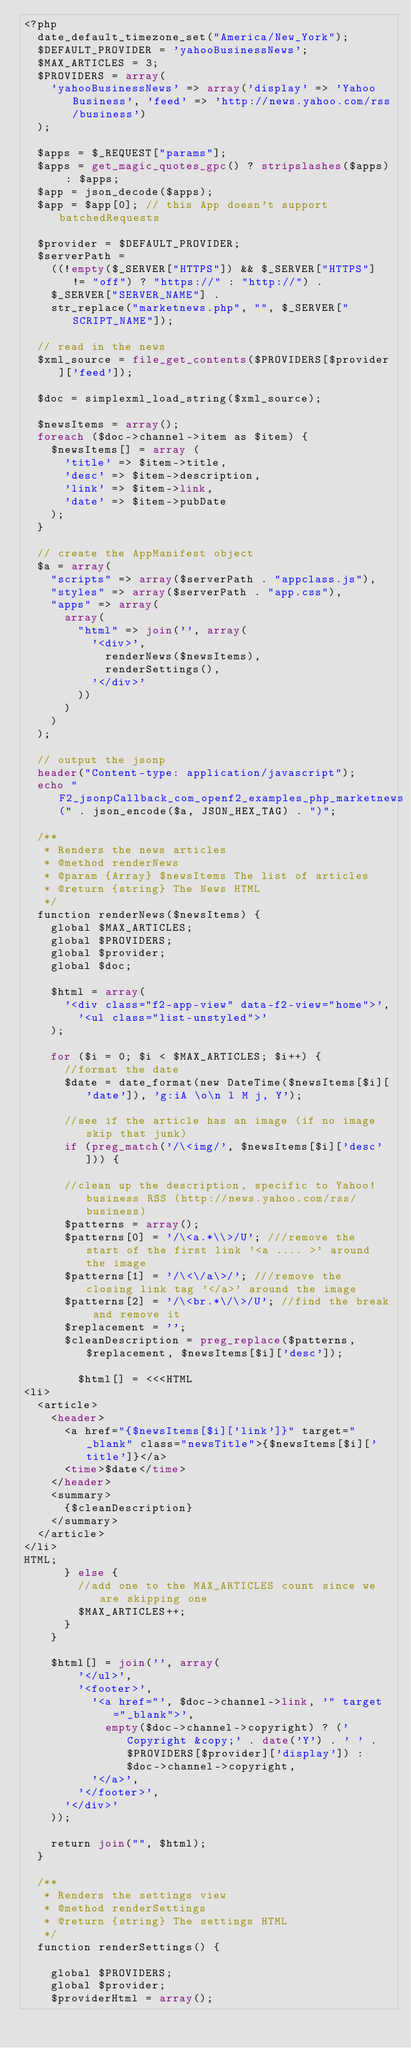<code> <loc_0><loc_0><loc_500><loc_500><_PHP_><?php
	date_default_timezone_set("America/New_York");
	$DEFAULT_PROVIDER = 'yahooBusinessNews';
	$MAX_ARTICLES = 3;
	$PROVIDERS = array(
		'yahooBusinessNews' => array('display' => 'Yahoo Business', 'feed' => 'http://news.yahoo.com/rss/business')
	);

	$apps = $_REQUEST["params"];
	$apps = get_magic_quotes_gpc() ? stripslashes($apps) : $apps;
	$app = json_decode($apps);  
	$app = $app[0]; // this App doesn't support batchedRequests

	$provider = $DEFAULT_PROVIDER;
	$serverPath = 
		((!empty($_SERVER["HTTPS"]) && $_SERVER["HTTPS"] != "off") ? "https://" : "http://") .
		$_SERVER["SERVER_NAME"] .
		str_replace("marketnews.php", "", $_SERVER["SCRIPT_NAME"]);

	// read in the news
	$xml_source = file_get_contents($PROVIDERS[$provider]['feed']);
	
	$doc = simplexml_load_string($xml_source);

	$newsItems = array();
	foreach ($doc->channel->item as $item) {
		$newsItems[] = array ( 
			'title' => $item->title,
			'desc' => $item->description,
			'link' => $item->link,
			'date' => $item->pubDate
		);
  }

	// create the AppManifest object
	$a = array(
		"scripts" => array($serverPath . "appclass.js"),
		"styles" => array($serverPath . "app.css"),
		"apps" => array(
			array(
				"html" => join('', array(
					'<div>',
						renderNews($newsItems),
						renderSettings(),
					'</div>'
				))
			)
		)
	);

	// output the jsonp
	header("Content-type: application/javascript");
	echo "F2_jsonpCallback_com_openf2_examples_php_marketnews(" . json_encode($a, JSON_HEX_TAG) . ")";

	/**
	 * Renders the news articles
	 * @method renderNews
	 * @param {Array} $newsItems The list of articles
	 * @return {string} The News HTML
	 */
	function renderNews($newsItems) {
		global $MAX_ARTICLES;
		global $PROVIDERS;
		global $provider;
		global $doc;

		$html = array(
			'<div class="f2-app-view" data-f2-view="home">',
				'<ul class="list-unstyled">'
		);

		for ($i = 0; $i < $MAX_ARTICLES; $i++) {
			//format the date
			$date = date_format(new DateTime($newsItems[$i]['date']), 'g:iA \o\n l M j, Y');

			//see if the article has an image (if no image skip that junk)
			if (preg_match('/\<img/', $newsItems[$i]['desc'])) {

			//clean up the description, specific to Yahoo! business RSS (http://news.yahoo.com/rss/business)
			$patterns = array();
			$patterns[0] = '/\<a.*\\>/U'; ///remove the start of the first link '<a .... >' around the image
			$patterns[1] = '/\<\/a\>/'; ///remove the closing link tag '</a>' around the image
			$patterns[2] = '/\<br.*\/\>/U'; //find the break and remove it
			$replacement = '';
			$cleanDescription = preg_replace($patterns, $replacement, $newsItems[$i]['desc']);

				$html[] = <<<HTML
<li>
	<article>
		<header>
			<a href="{$newsItems[$i]['link']}" target="_blank" class="newsTitle">{$newsItems[$i]['title']}</a>
			<time>$date</time>
		</header>
		<summary>
			{$cleanDescription}
		</summary>
	</article>
</li>
HTML;
			} else {
				//add one to the MAX_ARTICLES count since we are skipping one
				$MAX_ARTICLES++;
			}
		}

		$html[] = join('', array(
				'</ul>',
				'<footer>',
					'<a href="', $doc->channel->link, '" target="_blank">',
						empty($doc->channel->copyright) ? ('Copyright &copy;' . date('Y') . ' ' . $PROVIDERS[$provider]['display']) : $doc->channel->copyright,
					'</a>',
				'</footer>',
			'</div>'
		));

		return join("", $html);
	}

	/**
	 * Renders the settings view
	 * @method renderSettings
	 * @return {string} The settings HTML
	 */
	function renderSettings() {

		global $PROVIDERS;
		global $provider;
		$providerHtml = array();
</code> 